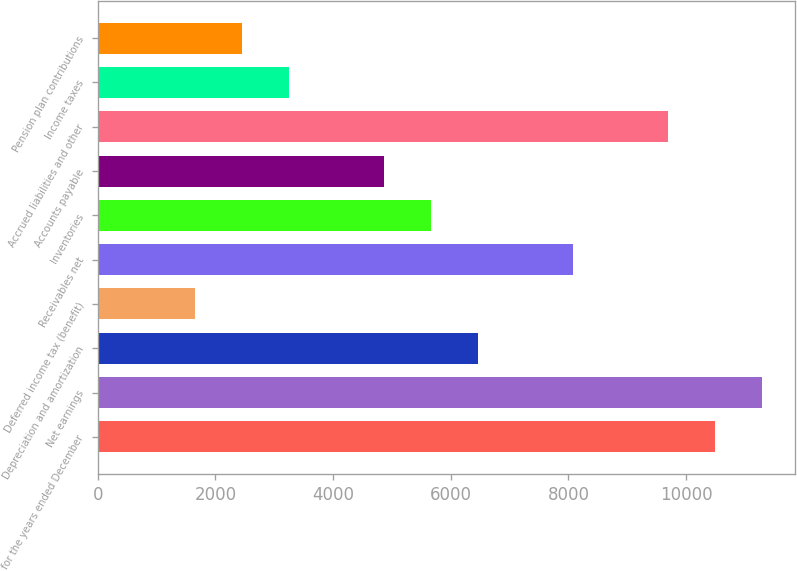Convert chart to OTSL. <chart><loc_0><loc_0><loc_500><loc_500><bar_chart><fcel>for the years ended December<fcel>Net earnings<fcel>Depreciation and amortization<fcel>Deferred income tax (benefit)<fcel>Receivables net<fcel>Inventories<fcel>Accounts payable<fcel>Accrued liabilities and other<fcel>Income taxes<fcel>Pension plan contributions<nl><fcel>10487.8<fcel>11291.4<fcel>6469.8<fcel>1648.2<fcel>8077<fcel>5666.2<fcel>4862.6<fcel>9684.2<fcel>3255.4<fcel>2451.8<nl></chart> 